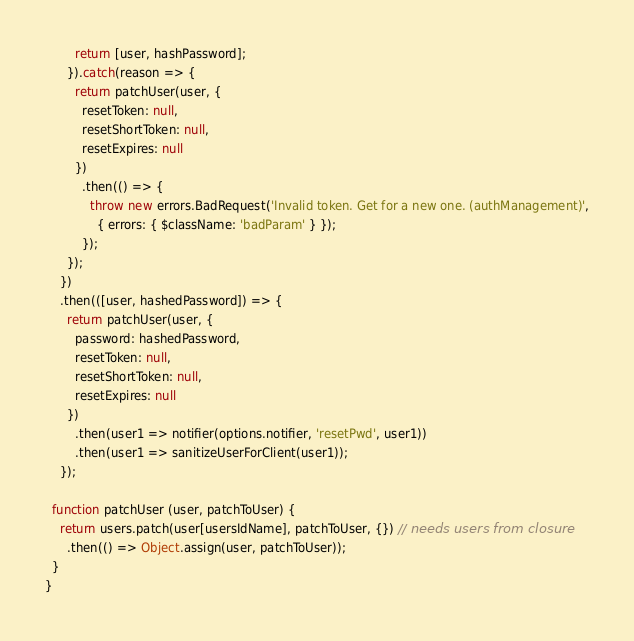<code> <loc_0><loc_0><loc_500><loc_500><_JavaScript_>        return [user, hashPassword];
      }).catch(reason => {
        return patchUser(user, {
          resetToken: null,
          resetShortToken: null,
          resetExpires: null
        })
          .then(() => {
            throw new errors.BadRequest('Invalid token. Get for a new one. (authManagement)',
              { errors: { $className: 'badParam' } });
          });
      });
    })
    .then(([user, hashedPassword]) => {
      return patchUser(user, {
        password: hashedPassword,
        resetToken: null,
        resetShortToken: null,
        resetExpires: null
      })
        .then(user1 => notifier(options.notifier, 'resetPwd', user1))
        .then(user1 => sanitizeUserForClient(user1));
    });

  function patchUser (user, patchToUser) {
    return users.patch(user[usersIdName], patchToUser, {}) // needs users from closure
      .then(() => Object.assign(user, patchToUser));
  }
}
</code> 